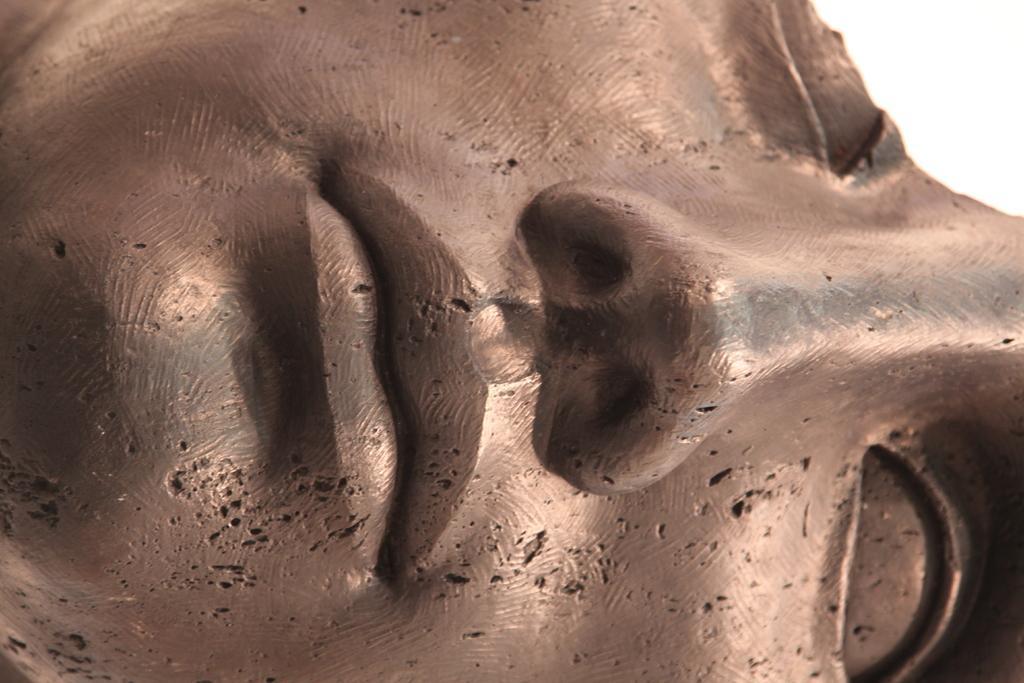Could you give a brief overview of what you see in this image? Here I can see a statue of a person's head. 